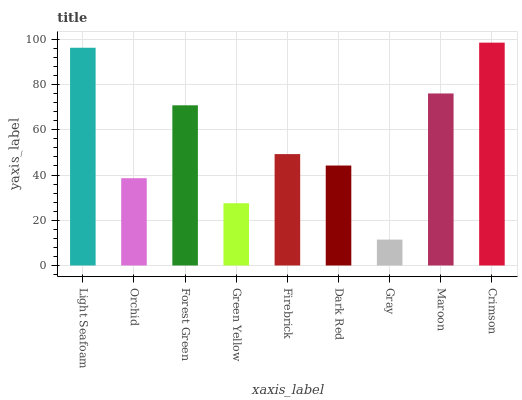Is Gray the minimum?
Answer yes or no. Yes. Is Crimson the maximum?
Answer yes or no. Yes. Is Orchid the minimum?
Answer yes or no. No. Is Orchid the maximum?
Answer yes or no. No. Is Light Seafoam greater than Orchid?
Answer yes or no. Yes. Is Orchid less than Light Seafoam?
Answer yes or no. Yes. Is Orchid greater than Light Seafoam?
Answer yes or no. No. Is Light Seafoam less than Orchid?
Answer yes or no. No. Is Firebrick the high median?
Answer yes or no. Yes. Is Firebrick the low median?
Answer yes or no. Yes. Is Orchid the high median?
Answer yes or no. No. Is Crimson the low median?
Answer yes or no. No. 